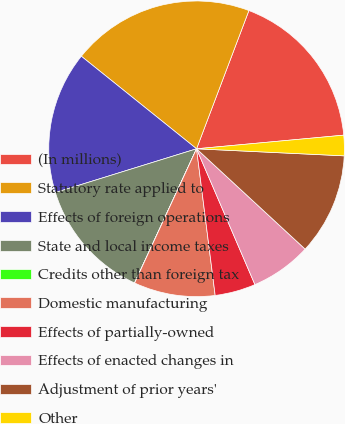Convert chart. <chart><loc_0><loc_0><loc_500><loc_500><pie_chart><fcel>(In millions)<fcel>Statutory rate applied to<fcel>Effects of foreign operations<fcel>State and local income taxes<fcel>Credits other than foreign tax<fcel>Domestic manufacturing<fcel>Effects of partially-owned<fcel>Effects of enacted changes in<fcel>Adjustment of prior years'<fcel>Other<nl><fcel>17.77%<fcel>19.99%<fcel>15.55%<fcel>13.33%<fcel>0.01%<fcel>8.89%<fcel>4.45%<fcel>6.67%<fcel>11.11%<fcel>2.23%<nl></chart> 